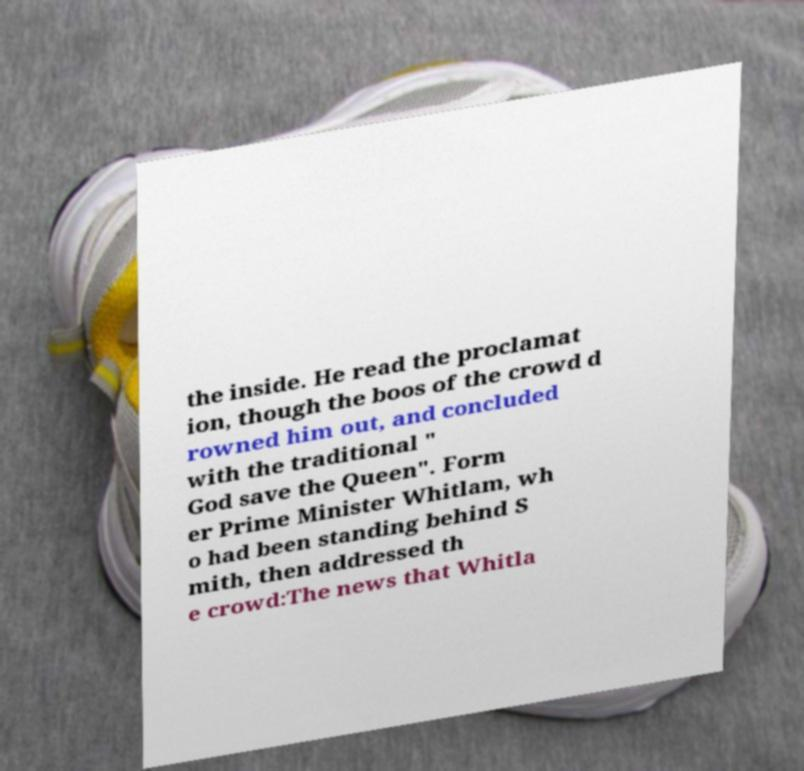Can you accurately transcribe the text from the provided image for me? the inside. He read the proclamat ion, though the boos of the crowd d rowned him out, and concluded with the traditional " God save the Queen". Form er Prime Minister Whitlam, wh o had been standing behind S mith, then addressed th e crowd:The news that Whitla 